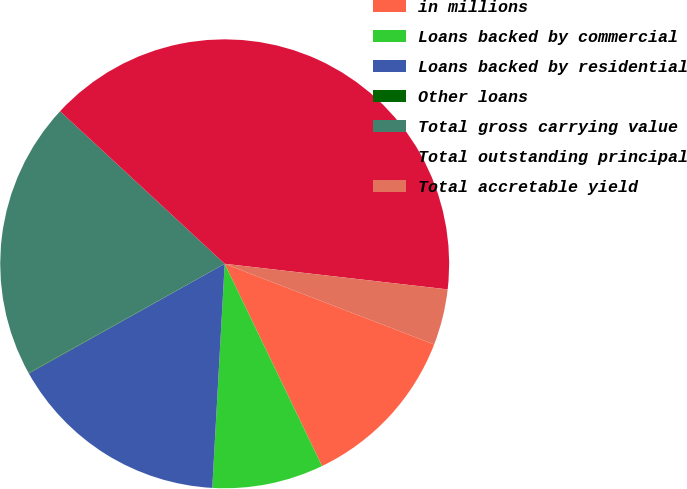Convert chart. <chart><loc_0><loc_0><loc_500><loc_500><pie_chart><fcel>in millions<fcel>Loans backed by commercial<fcel>Loans backed by residential<fcel>Other loans<fcel>Total gross carrying value<fcel>Total outstanding principal<fcel>Total accretable yield<nl><fcel>12.01%<fcel>8.02%<fcel>15.99%<fcel>0.04%<fcel>19.98%<fcel>39.92%<fcel>4.03%<nl></chart> 